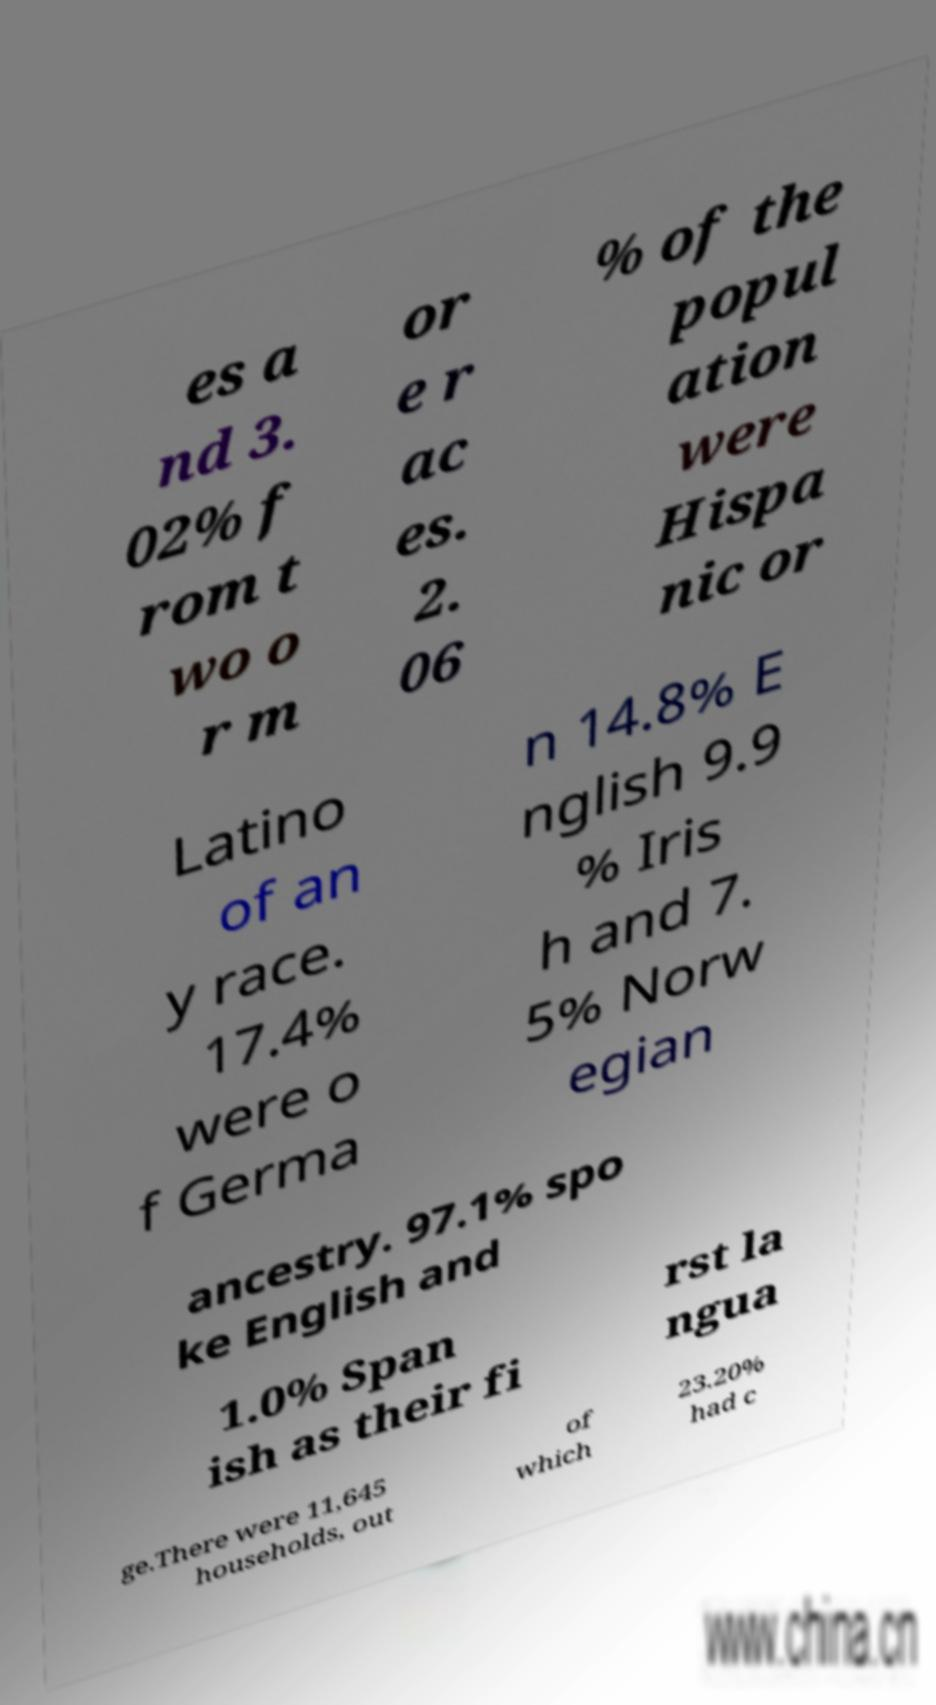Can you accurately transcribe the text from the provided image for me? es a nd 3. 02% f rom t wo o r m or e r ac es. 2. 06 % of the popul ation were Hispa nic or Latino of an y race. 17.4% were o f Germa n 14.8% E nglish 9.9 % Iris h and 7. 5% Norw egian ancestry. 97.1% spo ke English and 1.0% Span ish as their fi rst la ngua ge.There were 11,645 households, out of which 23.20% had c 